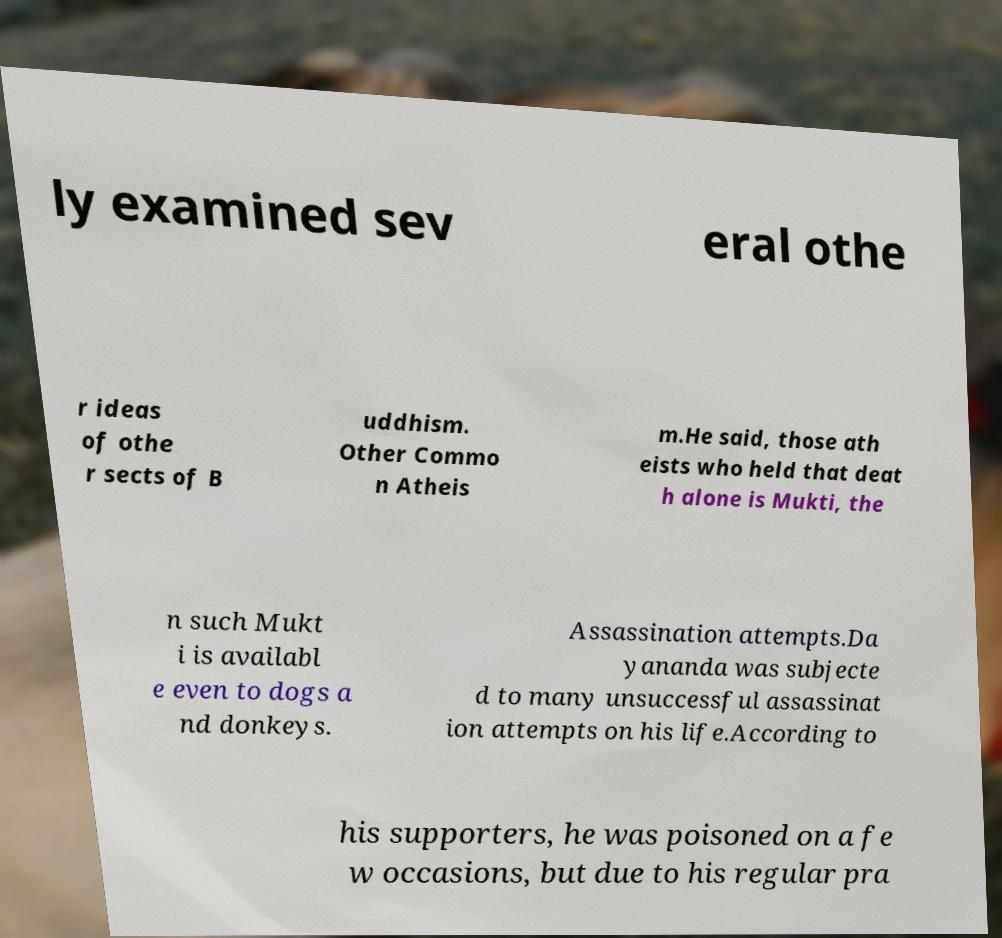Can you read and provide the text displayed in the image?This photo seems to have some interesting text. Can you extract and type it out for me? ly examined sev eral othe r ideas of othe r sects of B uddhism. Other Commo n Atheis m.He said, those ath eists who held that deat h alone is Mukti, the n such Mukt i is availabl e even to dogs a nd donkeys. Assassination attempts.Da yananda was subjecte d to many unsuccessful assassinat ion attempts on his life.According to his supporters, he was poisoned on a fe w occasions, but due to his regular pra 